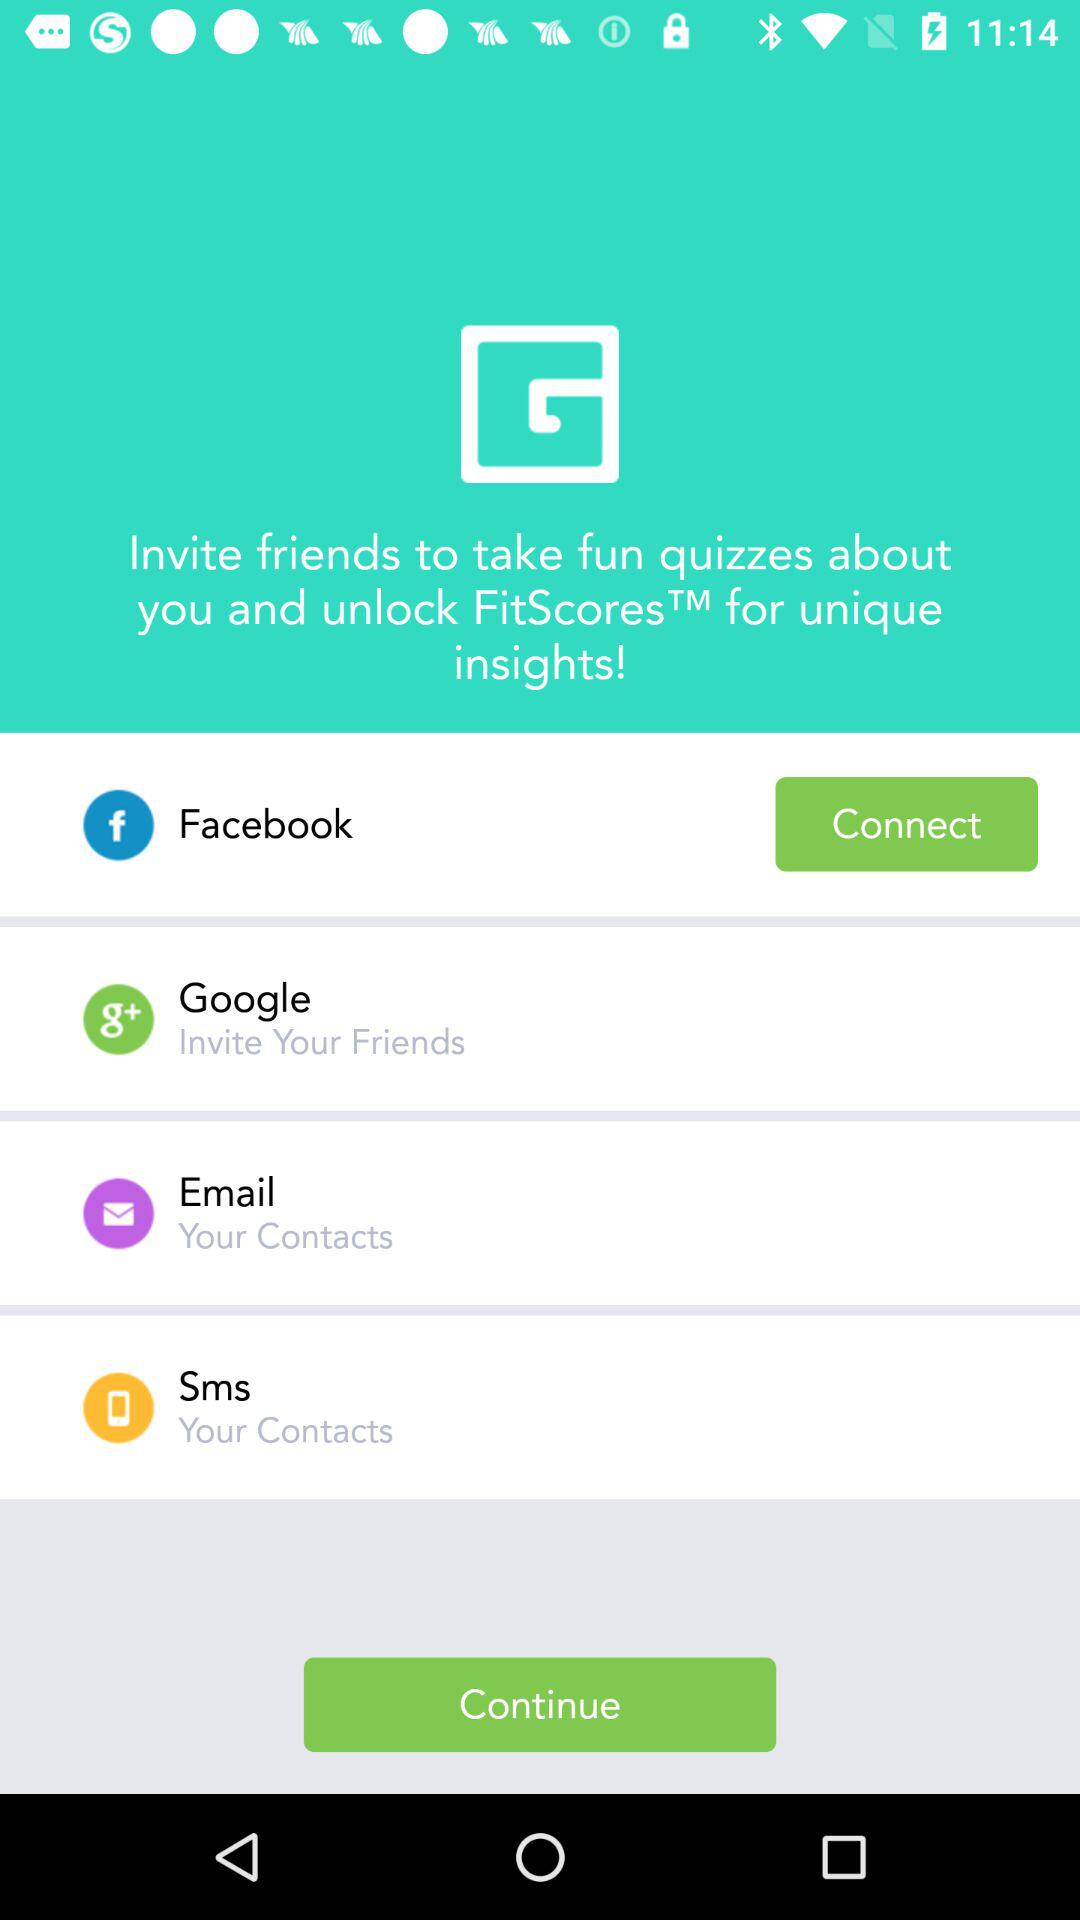Through which option can the user invite their contacts? The option through which the user can invite their contacts is "Google". 